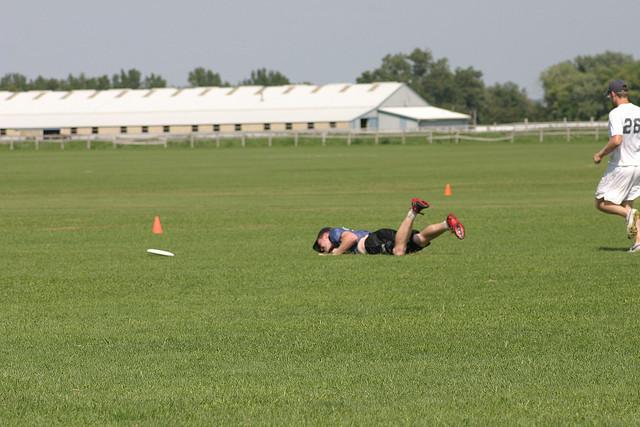What kind of animals are pictured?
Keep it brief. 0. What is in the grass?
Short answer required. Man. What are the orange things on the field?
Keep it brief. Cones. Did he catch the disc?
Concise answer only. No. What color are the bottom of his shoes?
Short answer required. Red. 